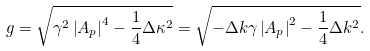<formula> <loc_0><loc_0><loc_500><loc_500>\ g = \sqrt { \gamma ^ { 2 } \left | A _ { p } \right | ^ { 4 } - \frac { 1 } { 4 } \Delta \kappa ^ { 2 } } = \sqrt { - \Delta k \gamma \left | A _ { p } \right | ^ { 2 } - \frac { 1 } { 4 } \Delta k ^ { 2 } } .</formula> 